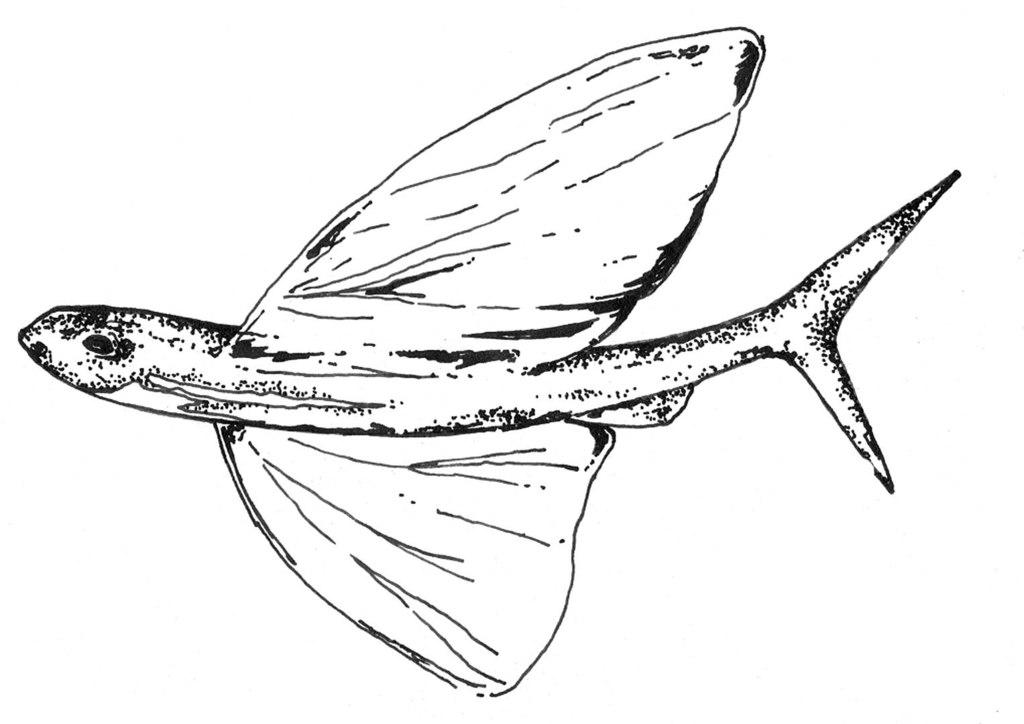What is depicted in the image? There is a drawing of a fish in the image. What color is the background of the image? The background of the image is white. Can you see a locket hanging from the fish's mouth in the image? There is no locket present in the image; it features a drawing of a fish with a white background. How many robins are visible in the image? There are no robins present in the image. 